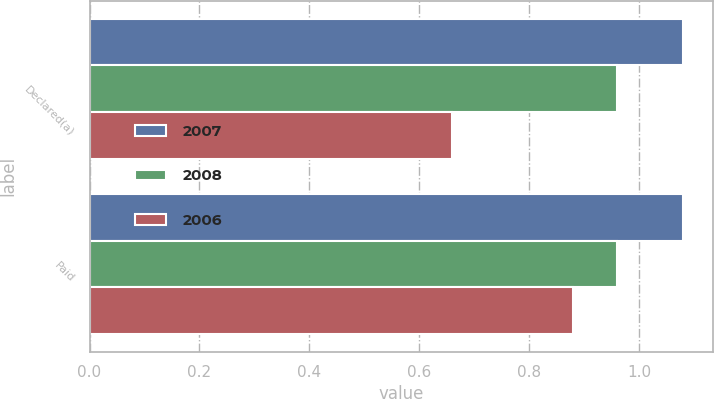<chart> <loc_0><loc_0><loc_500><loc_500><stacked_bar_chart><ecel><fcel>Declared(a)<fcel>Paid<nl><fcel>2007<fcel>1.08<fcel>1.08<nl><fcel>2008<fcel>0.96<fcel>0.96<nl><fcel>2006<fcel>0.66<fcel>0.88<nl></chart> 